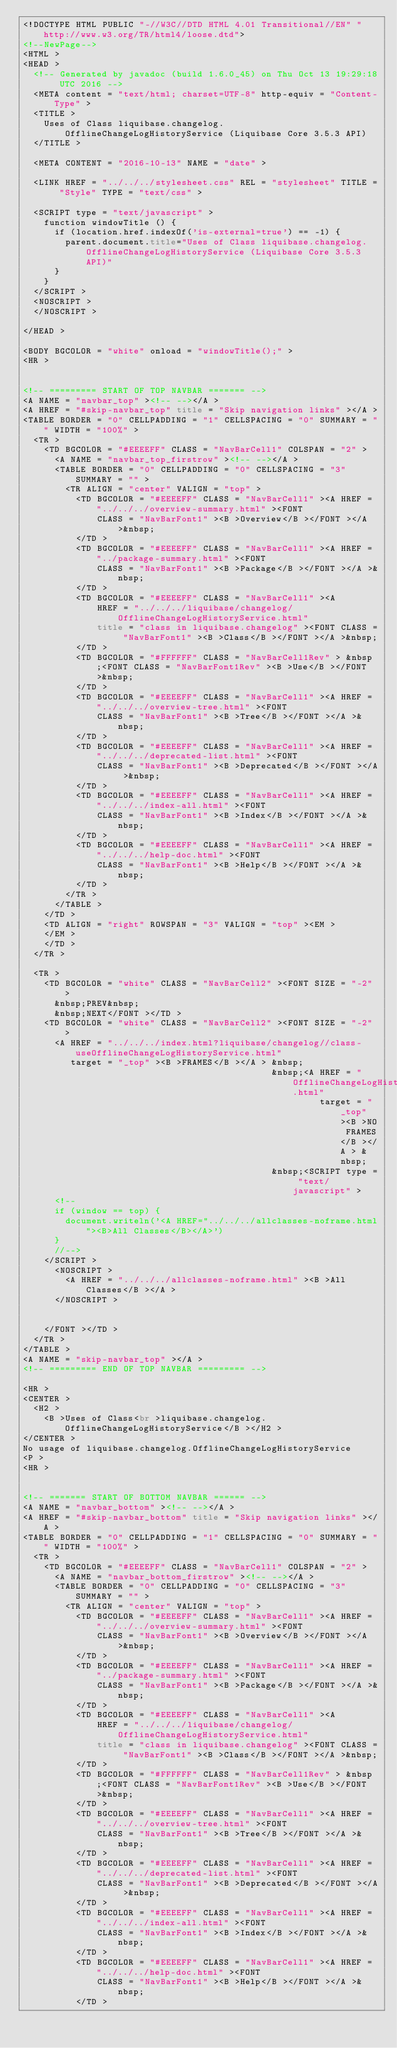Convert code to text. <code><loc_0><loc_0><loc_500><loc_500><_HTML_><!DOCTYPE HTML PUBLIC "-//W3C//DTD HTML 4.01 Transitional//EN" "http://www.w3.org/TR/html4/loose.dtd">
<!--NewPage-->
<HTML >
<HEAD >
	<!-- Generated by javadoc (build 1.6.0_45) on Thu Oct 13 19:29:18 UTC 2016 -->
	<META content = "text/html; charset=UTF-8" http-equiv = "Content-Type" >
	<TITLE >
		Uses of Class liquibase.changelog.OfflineChangeLogHistoryService (Liquibase Core 3.5.3 API)
	</TITLE >

	<META CONTENT = "2016-10-13" NAME = "date" >

	<LINK HREF = "../../../stylesheet.css" REL = "stylesheet" TITLE = "Style" TYPE = "text/css" >

	<SCRIPT type = "text/javascript" >
		function windowTitle () {
			if (location.href.indexOf('is-external=true') == -1) {
				parent.document.title="Uses of Class liquibase.changelog.OfflineChangeLogHistoryService (Liquibase Core 3.5.3 API)"
			}
		}
	</SCRIPT >
	<NOSCRIPT >
	</NOSCRIPT >

</HEAD >

<BODY BGCOLOR = "white" onload = "windowTitle();" >
<HR >


<!-- ========= START OF TOP NAVBAR ======= -->
<A NAME = "navbar_top" ><!-- --></A >
<A HREF = "#skip-navbar_top" title = "Skip navigation links" ></A >
<TABLE BORDER = "0" CELLPADDING = "1" CELLSPACING = "0" SUMMARY = "" WIDTH = "100%" >
	<TR >
		<TD BGCOLOR = "#EEEEFF" CLASS = "NavBarCell1" COLSPAN = "2" >
			<A NAME = "navbar_top_firstrow" ><!-- --></A >
			<TABLE BORDER = "0" CELLPADDING = "0" CELLSPACING = "3" SUMMARY = "" >
				<TR ALIGN = "center" VALIGN = "top" >
					<TD BGCOLOR = "#EEEEFF" CLASS = "NavBarCell1" ><A HREF = "../../../overview-summary.html" ><FONT
							CLASS = "NavBarFont1" ><B >Overview</B ></FONT ></A >&nbsp;
					</TD >
					<TD BGCOLOR = "#EEEEFF" CLASS = "NavBarCell1" ><A HREF = "../package-summary.html" ><FONT
							CLASS = "NavBarFont1" ><B >Package</B ></FONT ></A >&nbsp;
					</TD >
					<TD BGCOLOR = "#EEEEFF" CLASS = "NavBarCell1" ><A
							HREF = "../../../liquibase/changelog/OfflineChangeLogHistoryService.html"
							title = "class in liquibase.changelog" ><FONT CLASS = "NavBarFont1" ><B >Class</B ></FONT ></A >&nbsp;
					</TD >
					<TD BGCOLOR = "#FFFFFF" CLASS = "NavBarCell1Rev" > &nbsp;<FONT CLASS = "NavBarFont1Rev" ><B >Use</B ></FONT >&nbsp;
					</TD >
					<TD BGCOLOR = "#EEEEFF" CLASS = "NavBarCell1" ><A HREF = "../../../overview-tree.html" ><FONT
							CLASS = "NavBarFont1" ><B >Tree</B ></FONT ></A >&nbsp;
					</TD >
					<TD BGCOLOR = "#EEEEFF" CLASS = "NavBarCell1" ><A HREF = "../../../deprecated-list.html" ><FONT
							CLASS = "NavBarFont1" ><B >Deprecated</B ></FONT ></A >&nbsp;
					</TD >
					<TD BGCOLOR = "#EEEEFF" CLASS = "NavBarCell1" ><A HREF = "../../../index-all.html" ><FONT
							CLASS = "NavBarFont1" ><B >Index</B ></FONT ></A >&nbsp;
					</TD >
					<TD BGCOLOR = "#EEEEFF" CLASS = "NavBarCell1" ><A HREF = "../../../help-doc.html" ><FONT
							CLASS = "NavBarFont1" ><B >Help</B ></FONT ></A >&nbsp;
					</TD >
				</TR >
			</TABLE >
		</TD >
		<TD ALIGN = "right" ROWSPAN = "3" VALIGN = "top" ><EM >
		</EM >
		</TD >
	</TR >

	<TR >
		<TD BGCOLOR = "white" CLASS = "NavBarCell2" ><FONT SIZE = "-2" >
			&nbsp;PREV&nbsp;
			&nbsp;NEXT</FONT ></TD >
		<TD BGCOLOR = "white" CLASS = "NavBarCell2" ><FONT SIZE = "-2" >
			<A HREF = "../../../index.html?liquibase/changelog//class-useOfflineChangeLogHistoryService.html"
			   target = "_top" ><B >FRAMES</B ></A > &nbsp;
			                                         &nbsp;<A HREF = "OfflineChangeLogHistoryService.html"
			                                                  target = "_top" ><B >NO FRAMES</B ></A > &nbsp;
			                                         &nbsp;<SCRIPT type = "text/javascript" >
			<!--
			if (window == top) {
				document.writeln('<A HREF="../../../allclasses-noframe.html"><B>All Classes</B></A>')
			}
			//-->
		</SCRIPT >
			<NOSCRIPT >
				<A HREF = "../../../allclasses-noframe.html" ><B >All Classes</B ></A >
			</NOSCRIPT >


		</FONT ></TD >
	</TR >
</TABLE >
<A NAME = "skip-navbar_top" ></A >
<!-- ========= END OF TOP NAVBAR ========= -->

<HR >
<CENTER >
	<H2 >
		<B >Uses of Class<br >liquibase.changelog.OfflineChangeLogHistoryService</B ></H2 >
</CENTER >
No usage of liquibase.changelog.OfflineChangeLogHistoryService
<P >
<HR >


<!-- ======= START OF BOTTOM NAVBAR ====== -->
<A NAME = "navbar_bottom" ><!-- --></A >
<A HREF = "#skip-navbar_bottom" title = "Skip navigation links" ></A >
<TABLE BORDER = "0" CELLPADDING = "1" CELLSPACING = "0" SUMMARY = "" WIDTH = "100%" >
	<TR >
		<TD BGCOLOR = "#EEEEFF" CLASS = "NavBarCell1" COLSPAN = "2" >
			<A NAME = "navbar_bottom_firstrow" ><!-- --></A >
			<TABLE BORDER = "0" CELLPADDING = "0" CELLSPACING = "3" SUMMARY = "" >
				<TR ALIGN = "center" VALIGN = "top" >
					<TD BGCOLOR = "#EEEEFF" CLASS = "NavBarCell1" ><A HREF = "../../../overview-summary.html" ><FONT
							CLASS = "NavBarFont1" ><B >Overview</B ></FONT ></A >&nbsp;
					</TD >
					<TD BGCOLOR = "#EEEEFF" CLASS = "NavBarCell1" ><A HREF = "../package-summary.html" ><FONT
							CLASS = "NavBarFont1" ><B >Package</B ></FONT ></A >&nbsp;
					</TD >
					<TD BGCOLOR = "#EEEEFF" CLASS = "NavBarCell1" ><A
							HREF = "../../../liquibase/changelog/OfflineChangeLogHistoryService.html"
							title = "class in liquibase.changelog" ><FONT CLASS = "NavBarFont1" ><B >Class</B ></FONT ></A >&nbsp;
					</TD >
					<TD BGCOLOR = "#FFFFFF" CLASS = "NavBarCell1Rev" > &nbsp;<FONT CLASS = "NavBarFont1Rev" ><B >Use</B ></FONT >&nbsp;
					</TD >
					<TD BGCOLOR = "#EEEEFF" CLASS = "NavBarCell1" ><A HREF = "../../../overview-tree.html" ><FONT
							CLASS = "NavBarFont1" ><B >Tree</B ></FONT ></A >&nbsp;
					</TD >
					<TD BGCOLOR = "#EEEEFF" CLASS = "NavBarCell1" ><A HREF = "../../../deprecated-list.html" ><FONT
							CLASS = "NavBarFont1" ><B >Deprecated</B ></FONT ></A >&nbsp;
					</TD >
					<TD BGCOLOR = "#EEEEFF" CLASS = "NavBarCell1" ><A HREF = "../../../index-all.html" ><FONT
							CLASS = "NavBarFont1" ><B >Index</B ></FONT ></A >&nbsp;
					</TD >
					<TD BGCOLOR = "#EEEEFF" CLASS = "NavBarCell1" ><A HREF = "../../../help-doc.html" ><FONT
							CLASS = "NavBarFont1" ><B >Help</B ></FONT ></A >&nbsp;
					</TD ></code> 